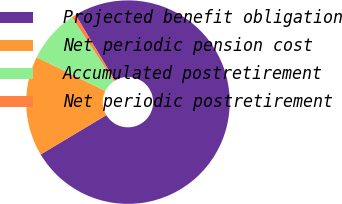Convert chart. <chart><loc_0><loc_0><loc_500><loc_500><pie_chart><fcel>Projected benefit obligation<fcel>Net periodic pension cost<fcel>Accumulated postretirement<fcel>Net periodic postretirement<nl><fcel>75.02%<fcel>15.88%<fcel>8.44%<fcel>0.66%<nl></chart> 